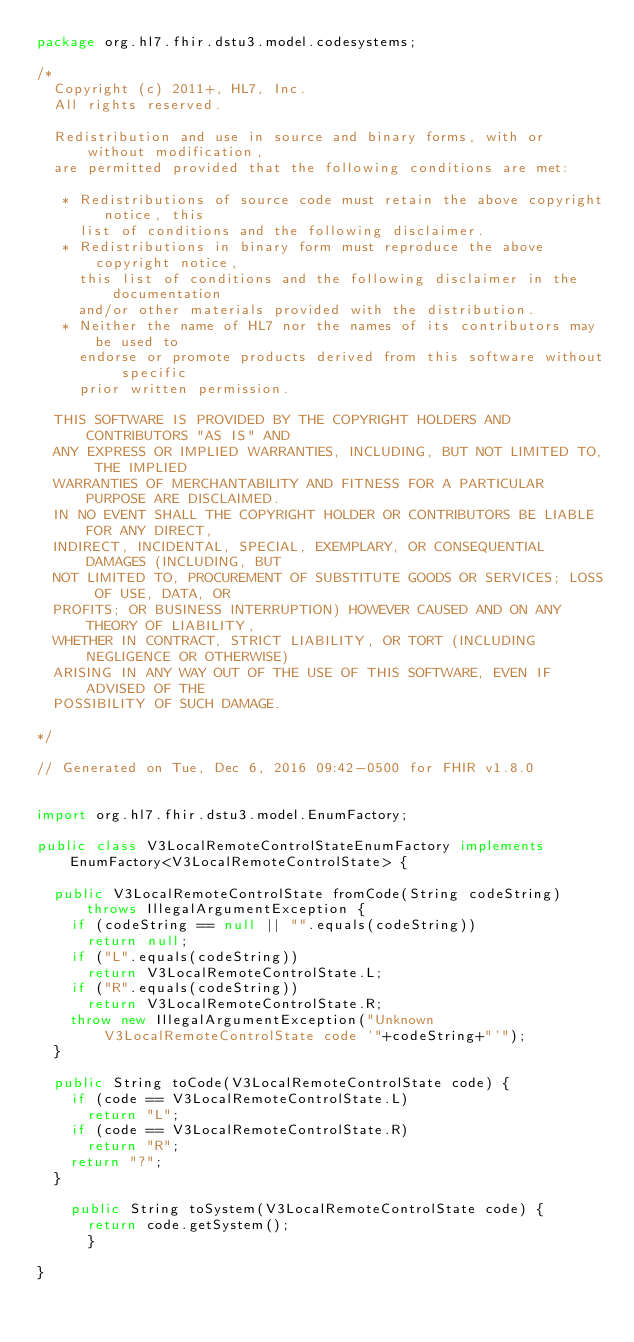Convert code to text. <code><loc_0><loc_0><loc_500><loc_500><_Java_>package org.hl7.fhir.dstu3.model.codesystems;

/*
  Copyright (c) 2011+, HL7, Inc.
  All rights reserved.
  
  Redistribution and use in source and binary forms, with or without modification, 
  are permitted provided that the following conditions are met:
  
   * Redistributions of source code must retain the above copyright notice, this 
     list of conditions and the following disclaimer.
   * Redistributions in binary form must reproduce the above copyright notice, 
     this list of conditions and the following disclaimer in the documentation 
     and/or other materials provided with the distribution.
   * Neither the name of HL7 nor the names of its contributors may be used to 
     endorse or promote products derived from this software without specific 
     prior written permission.
  
  THIS SOFTWARE IS PROVIDED BY THE COPYRIGHT HOLDERS AND CONTRIBUTORS "AS IS" AND 
  ANY EXPRESS OR IMPLIED WARRANTIES, INCLUDING, BUT NOT LIMITED TO, THE IMPLIED 
  WARRANTIES OF MERCHANTABILITY AND FITNESS FOR A PARTICULAR PURPOSE ARE DISCLAIMED. 
  IN NO EVENT SHALL THE COPYRIGHT HOLDER OR CONTRIBUTORS BE LIABLE FOR ANY DIRECT, 
  INDIRECT, INCIDENTAL, SPECIAL, EXEMPLARY, OR CONSEQUENTIAL DAMAGES (INCLUDING, BUT 
  NOT LIMITED TO, PROCUREMENT OF SUBSTITUTE GOODS OR SERVICES; LOSS OF USE, DATA, OR 
  PROFITS; OR BUSINESS INTERRUPTION) HOWEVER CAUSED AND ON ANY THEORY OF LIABILITY, 
  WHETHER IN CONTRACT, STRICT LIABILITY, OR TORT (INCLUDING NEGLIGENCE OR OTHERWISE) 
  ARISING IN ANY WAY OUT OF THE USE OF THIS SOFTWARE, EVEN IF ADVISED OF THE 
  POSSIBILITY OF SUCH DAMAGE.
  
*/

// Generated on Tue, Dec 6, 2016 09:42-0500 for FHIR v1.8.0


import org.hl7.fhir.dstu3.model.EnumFactory;

public class V3LocalRemoteControlStateEnumFactory implements EnumFactory<V3LocalRemoteControlState> {

  public V3LocalRemoteControlState fromCode(String codeString) throws IllegalArgumentException {
    if (codeString == null || "".equals(codeString))
      return null;
    if ("L".equals(codeString))
      return V3LocalRemoteControlState.L;
    if ("R".equals(codeString))
      return V3LocalRemoteControlState.R;
    throw new IllegalArgumentException("Unknown V3LocalRemoteControlState code '"+codeString+"'");
  }

  public String toCode(V3LocalRemoteControlState code) {
    if (code == V3LocalRemoteControlState.L)
      return "L";
    if (code == V3LocalRemoteControlState.R)
      return "R";
    return "?";
  }

    public String toSystem(V3LocalRemoteControlState code) {
      return code.getSystem();
      }

}

</code> 